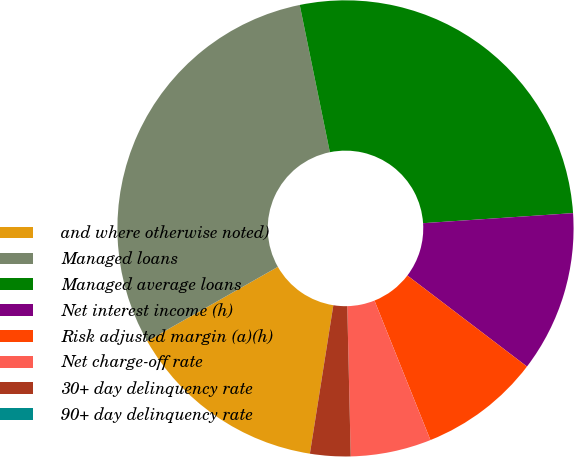Convert chart to OTSL. <chart><loc_0><loc_0><loc_500><loc_500><pie_chart><fcel>and where otherwise noted)<fcel>Managed loans<fcel>Managed average loans<fcel>Net interest income (h)<fcel>Risk adjusted margin (a)(h)<fcel>Net charge-off rate<fcel>30+ day delinquency rate<fcel>90+ day delinquency rate<nl><fcel>14.28%<fcel>30.01%<fcel>27.15%<fcel>11.42%<fcel>8.57%<fcel>5.71%<fcel>2.86%<fcel>0.0%<nl></chart> 